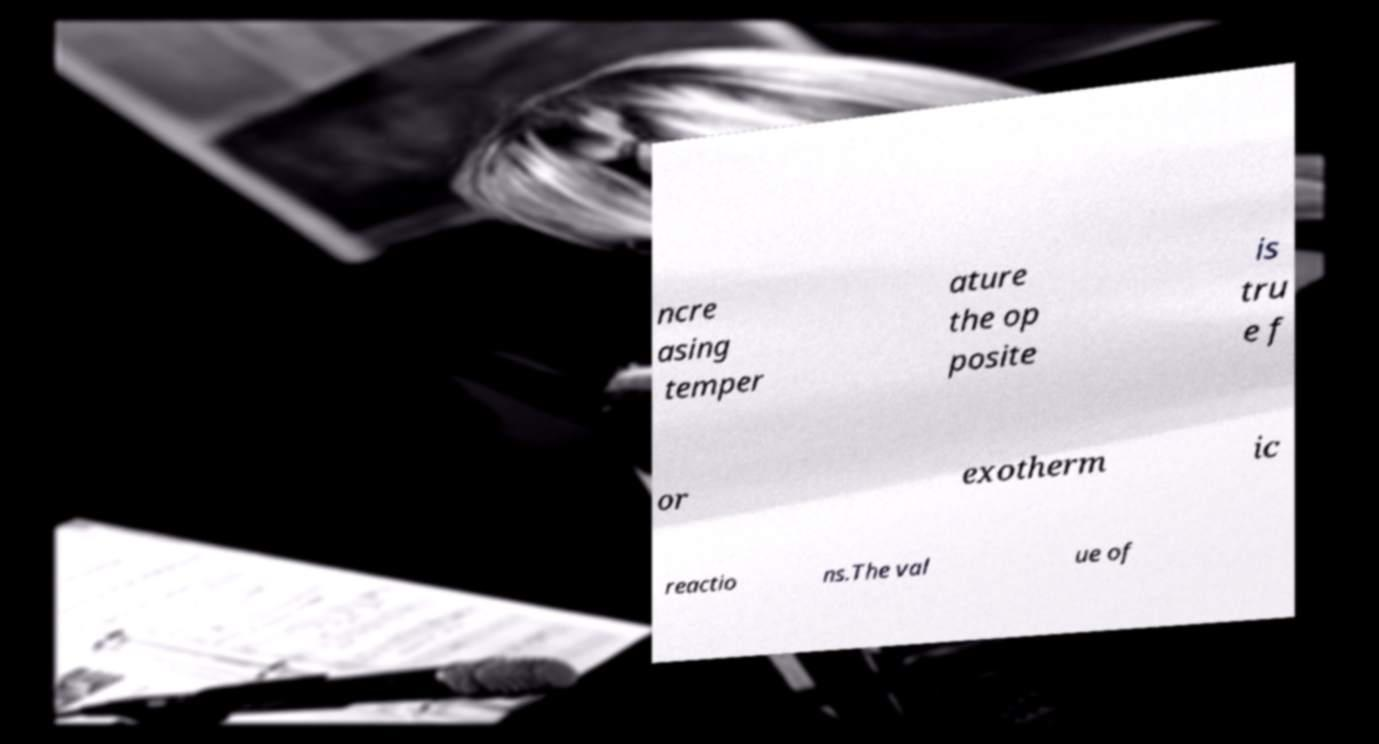Could you extract and type out the text from this image? ncre asing temper ature the op posite is tru e f or exotherm ic reactio ns.The val ue of 